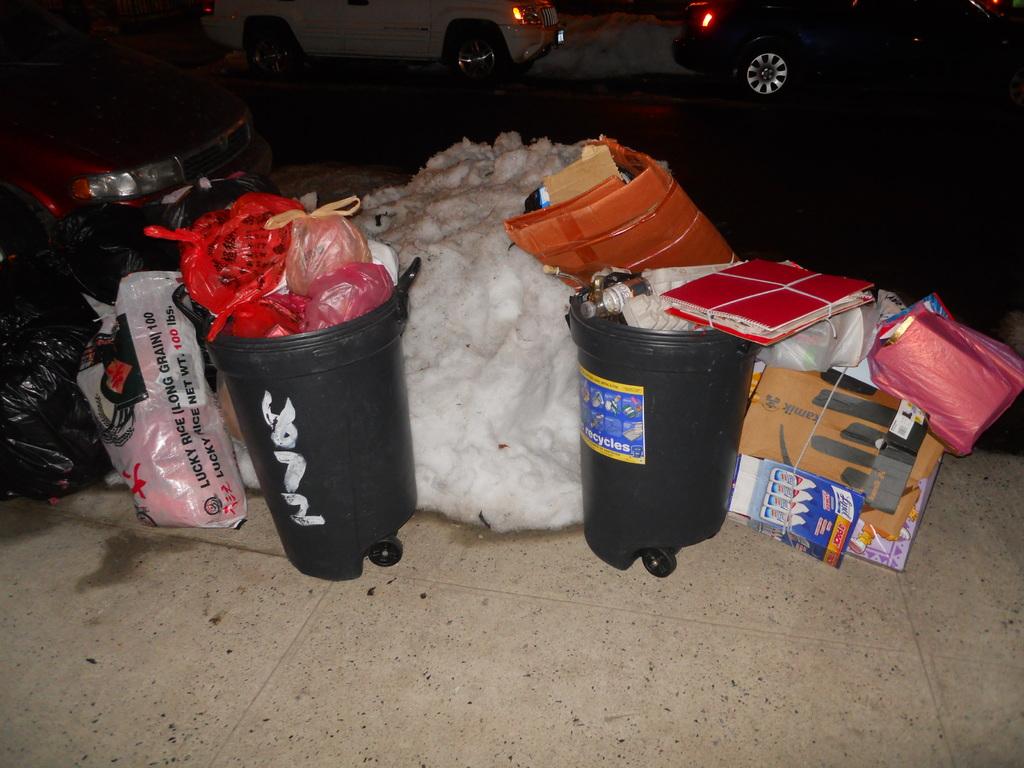How many pounds of lucky rice were in the bag?
Your answer should be very brief. 100. What is the number on the trash can?
Give a very brief answer. 872. 